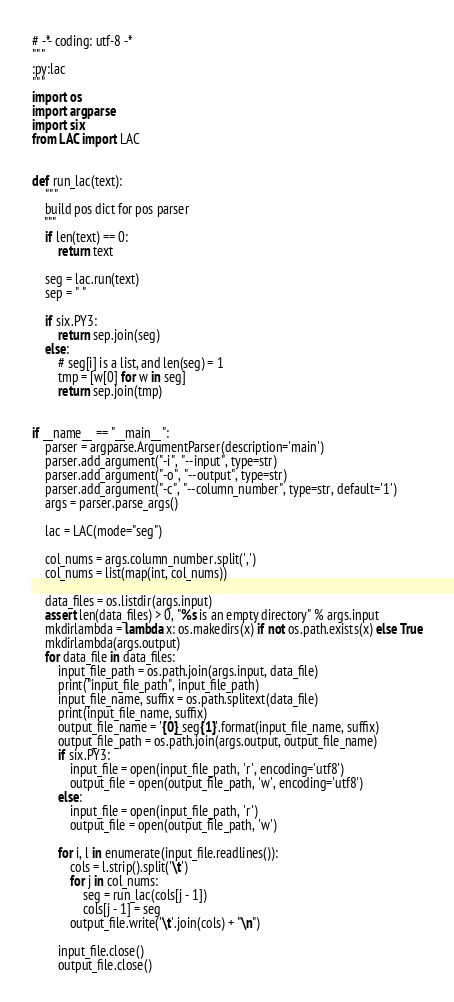<code> <loc_0><loc_0><loc_500><loc_500><_Python_># -*- coding: utf-8 -*
"""
:py:lac
"""
import os
import argparse
import six
from LAC import LAC


def run_lac(text):
    """
    build pos dict for pos parser
    """
    if len(text) == 0:
        return text

    seg = lac.run(text)
    sep = " "

    if six.PY3:
        return sep.join(seg)
    else:
        # seg[i] is a list, and len(seg) = 1
        tmp = [w[0] for w in seg]
        return sep.join(tmp)


if __name__ == "__main__":
    parser = argparse.ArgumentParser(description='main')
    parser.add_argument("-i", "--input", type=str)
    parser.add_argument("-o", "--output", type=str)
    parser.add_argument("-c", "--column_number", type=str, default='1')
    args = parser.parse_args()

    lac = LAC(mode="seg")

    col_nums = args.column_number.split(',')
    col_nums = list(map(int, col_nums))

    data_files = os.listdir(args.input)
    assert len(data_files) > 0, "%s is an empty directory" % args.input
    mkdirlambda = lambda x: os.makedirs(x) if not os.path.exists(x) else True
    mkdirlambda(args.output)
    for data_file in data_files:
        input_file_path = os.path.join(args.input, data_file)
        print("input_file_path", input_file_path)
        input_file_name, suffix = os.path.splitext(data_file)
        print(input_file_name, suffix)
        output_file_name = '{0}_seg{1}'.format(input_file_name, suffix)
        output_file_path = os.path.join(args.output, output_file_name)
        if six.PY3:
            input_file = open(input_file_path, 'r', encoding='utf8')
            output_file = open(output_file_path, 'w', encoding='utf8')
        else:
            input_file = open(input_file_path, 'r')
            output_file = open(output_file_path, 'w')

        for i, l in enumerate(input_file.readlines()):
            cols = l.strip().split('\t')
            for j in col_nums:
                seg = run_lac(cols[j - 1])
                cols[j - 1] = seg
            output_file.write('\t'.join(cols) + "\n")

        input_file.close()
        output_file.close()


</code> 